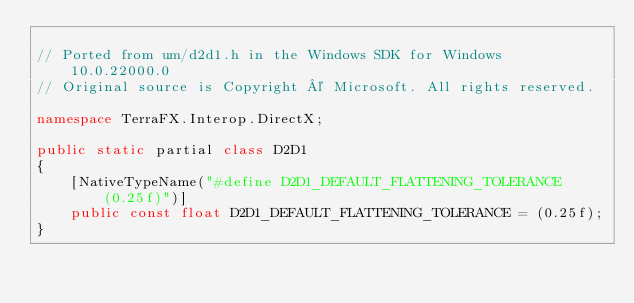Convert code to text. <code><loc_0><loc_0><loc_500><loc_500><_C#_>
// Ported from um/d2d1.h in the Windows SDK for Windows 10.0.22000.0
// Original source is Copyright © Microsoft. All rights reserved.

namespace TerraFX.Interop.DirectX;

public static partial class D2D1
{
    [NativeTypeName("#define D2D1_DEFAULT_FLATTENING_TOLERANCE (0.25f)")]
    public const float D2D1_DEFAULT_FLATTENING_TOLERANCE = (0.25f);
}
</code> 